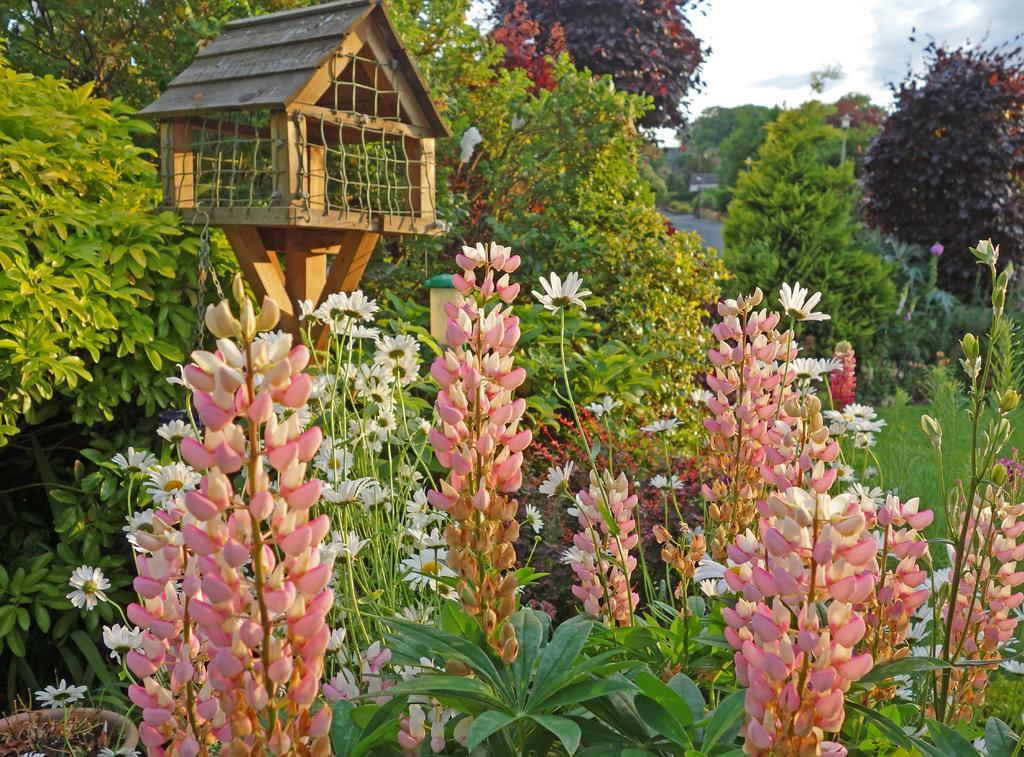How would you summarize this image in a sentence or two? As we can see in the image there are plants, trees, flowers, grass, sky and clouds. 